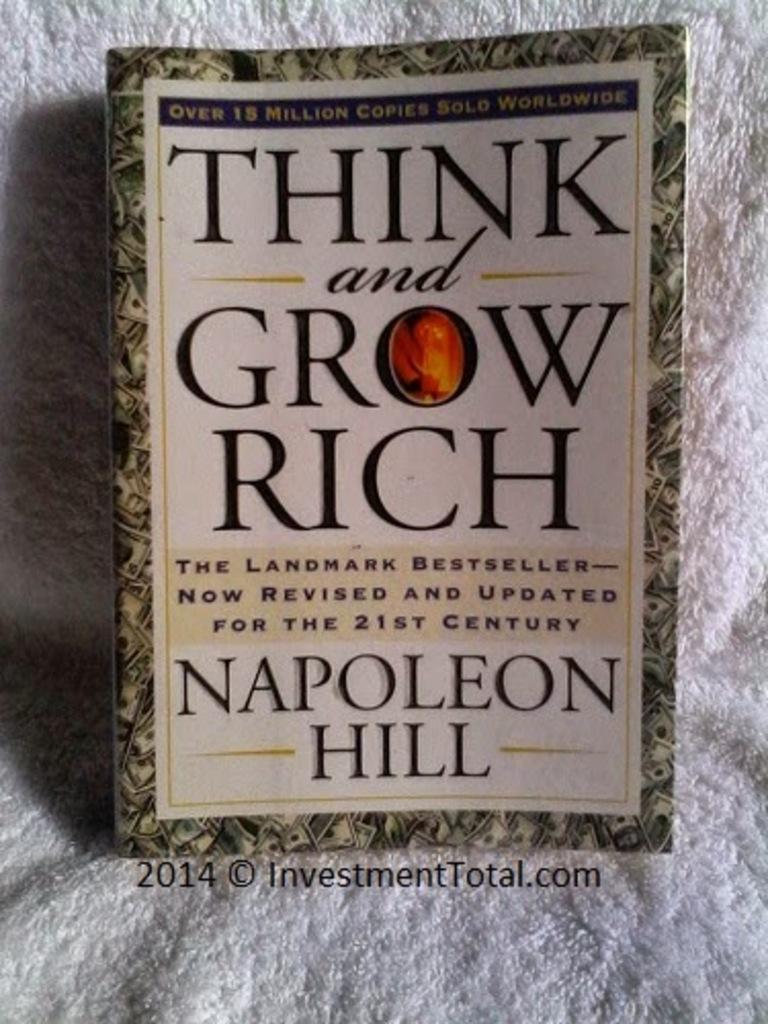What has the book been updated for?
Your answer should be very brief. The 21st century. Who wrote this book?
Offer a very short reply. Napoleon hill. 